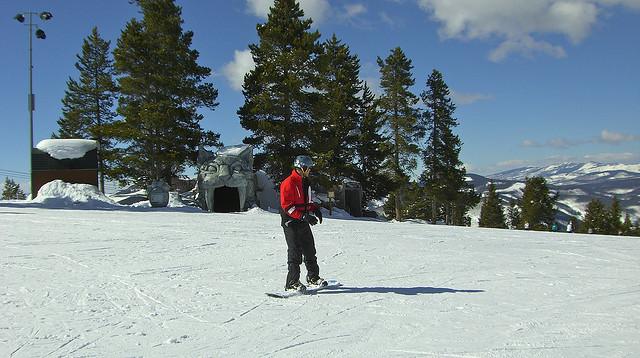Is it cold out?
Give a very brief answer. Yes. What are the trees covered in?
Give a very brief answer. Snow. What is the man holding?
Quick response, please. Gloves. Is the skier on a mountain?
Answer briefly. Yes. What is this person doing?
Short answer required. Snowboarding. In what activity is this woman engaging?
Keep it brief. Snowboarding. What color shirt is the man wearing?
Be succinct. Red. What are they doing?
Answer briefly. Snowboarding. Are they skiing?
Give a very brief answer. No. Are they snowboarding?
Quick response, please. Yes. 